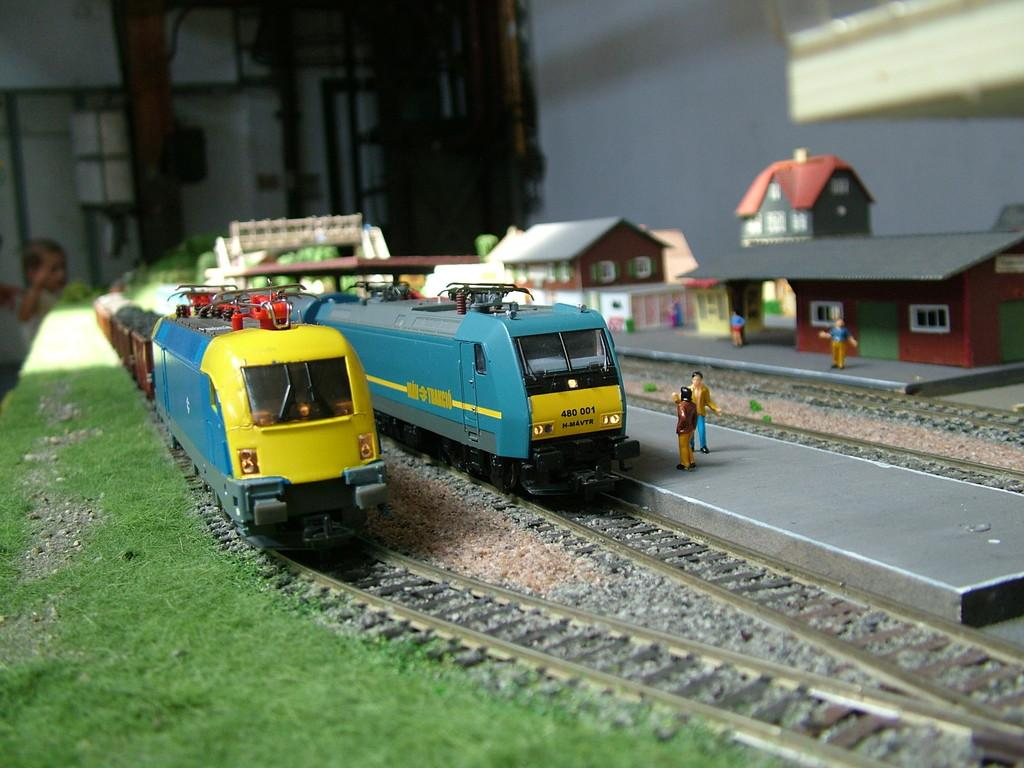What types of toys are present in the image? There are toys in the shape of a train on the track, toys in the shape of horses, and toys in the shape of people. Can you describe the train toy in the image? The train toy is on a track in the image. What type of terrain is visible in the image? There is grass visible in the image. What is the condition of the railway in the image? There is no railway present in the image; it features a train toy on a track. Is the image set during winter? The image does not provide any information about the season, so it cannot be determined if it is set during winter. 